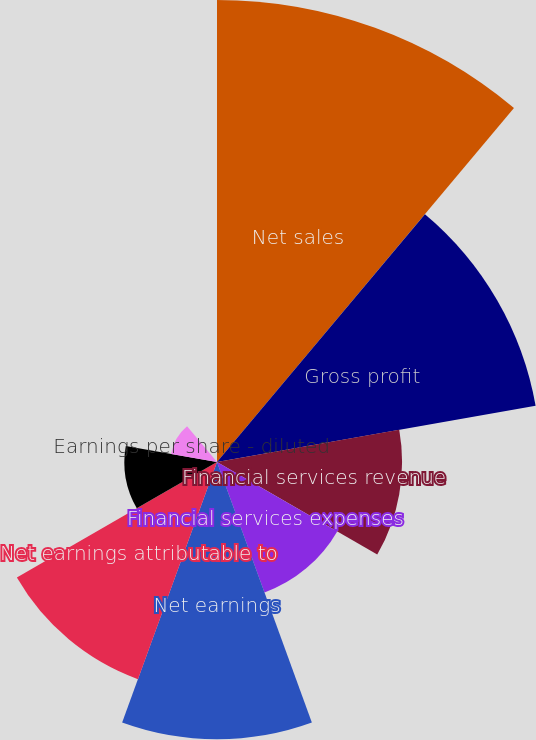<chart> <loc_0><loc_0><loc_500><loc_500><pie_chart><fcel>Net sales<fcel>Gross profit<fcel>Financial services revenue<fcel>Financial services expenses<fcel>Net earnings<fcel>Net earnings attributable to<fcel>Earnings per share - basic<fcel>Earnings per share - diluted<fcel>Cash dividends paid per share<nl><fcel>26.29%<fcel>18.41%<fcel>10.53%<fcel>7.9%<fcel>15.78%<fcel>13.15%<fcel>5.27%<fcel>2.65%<fcel>0.02%<nl></chart> 